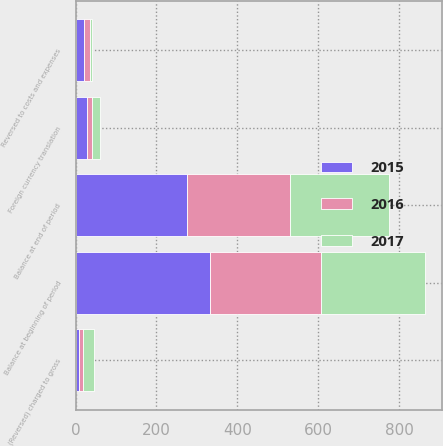Convert chart to OTSL. <chart><loc_0><loc_0><loc_500><loc_500><stacked_bar_chart><ecel><fcel>Balance at beginning of period<fcel>Reversed to costs and expenses<fcel>(Reversed) charged to gross<fcel>Foreign currency translation<fcel>Balance at end of period<nl><fcel>2017<fcel>255.6<fcel>4.6<fcel>27<fcel>19.3<fcel>243.3<nl><fcel>2016<fcel>275.1<fcel>15.4<fcel>9.5<fcel>13.6<fcel>255.6<nl><fcel>2015<fcel>332.2<fcel>20.8<fcel>9.2<fcel>27.1<fcel>275.1<nl></chart> 